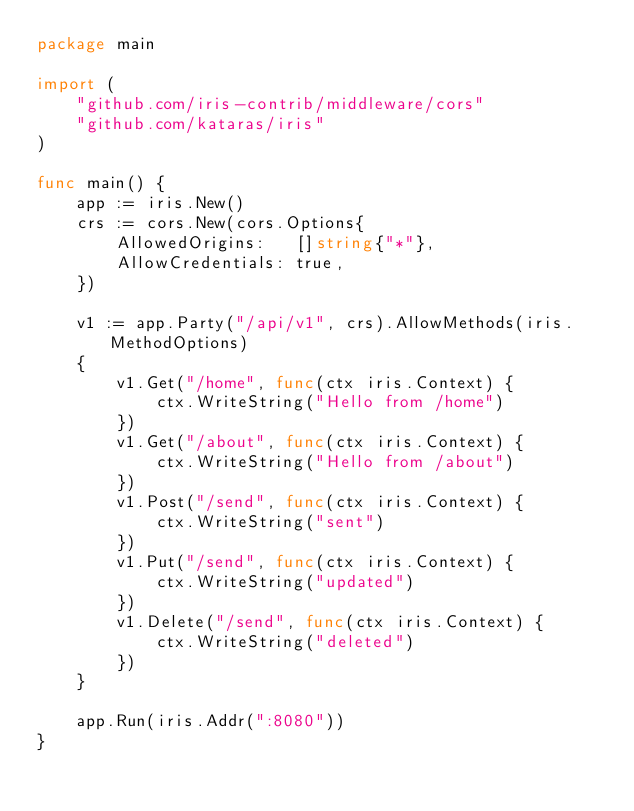<code> <loc_0><loc_0><loc_500><loc_500><_Go_>package main

import (
	"github.com/iris-contrib/middleware/cors"
	"github.com/kataras/iris"
)

func main() {
	app := iris.New()
	crs := cors.New(cors.Options{
		AllowedOrigins:   []string{"*"},
		AllowCredentials: true,
	})

	v1 := app.Party("/api/v1", crs).AllowMethods(iris.MethodOptions)
	{
		v1.Get("/home", func(ctx iris.Context) {
			ctx.WriteString("Hello from /home")
		})
		v1.Get("/about", func(ctx iris.Context) {
			ctx.WriteString("Hello from /about")
		})
		v1.Post("/send", func(ctx iris.Context) {
			ctx.WriteString("sent")
		})
		v1.Put("/send", func(ctx iris.Context) {
			ctx.WriteString("updated")
		})
		v1.Delete("/send", func(ctx iris.Context) {
			ctx.WriteString("deleted")
		})
	}

	app.Run(iris.Addr(":8080"))
}
</code> 